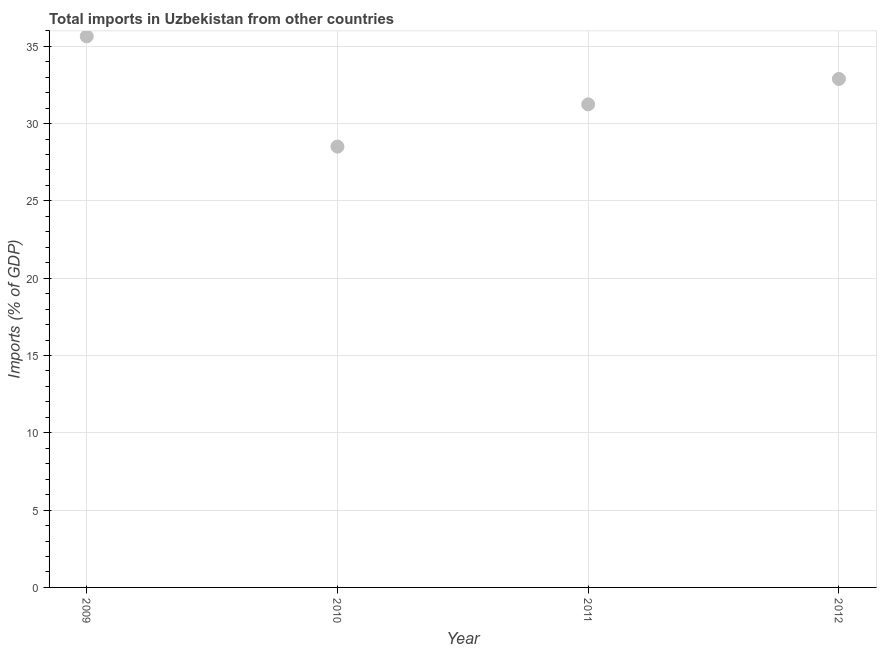What is the total imports in 2011?
Offer a terse response. 31.24. Across all years, what is the maximum total imports?
Make the answer very short. 35.65. Across all years, what is the minimum total imports?
Your answer should be compact. 28.51. What is the sum of the total imports?
Keep it short and to the point. 128.29. What is the difference between the total imports in 2009 and 2011?
Give a very brief answer. 4.4. What is the average total imports per year?
Your answer should be very brief. 32.07. What is the median total imports?
Ensure brevity in your answer.  32.07. What is the ratio of the total imports in 2011 to that in 2012?
Provide a short and direct response. 0.95. Is the total imports in 2009 less than that in 2011?
Ensure brevity in your answer.  No. What is the difference between the highest and the second highest total imports?
Make the answer very short. 2.76. Is the sum of the total imports in 2010 and 2011 greater than the maximum total imports across all years?
Your response must be concise. Yes. What is the difference between the highest and the lowest total imports?
Your response must be concise. 7.13. In how many years, is the total imports greater than the average total imports taken over all years?
Keep it short and to the point. 2. How many dotlines are there?
Keep it short and to the point. 1. What is the difference between two consecutive major ticks on the Y-axis?
Give a very brief answer. 5. Are the values on the major ticks of Y-axis written in scientific E-notation?
Ensure brevity in your answer.  No. Does the graph contain any zero values?
Your response must be concise. No. Does the graph contain grids?
Ensure brevity in your answer.  Yes. What is the title of the graph?
Provide a short and direct response. Total imports in Uzbekistan from other countries. What is the label or title of the Y-axis?
Provide a succinct answer. Imports (% of GDP). What is the Imports (% of GDP) in 2009?
Your answer should be compact. 35.65. What is the Imports (% of GDP) in 2010?
Your response must be concise. 28.51. What is the Imports (% of GDP) in 2011?
Offer a very short reply. 31.24. What is the Imports (% of GDP) in 2012?
Provide a succinct answer. 32.89. What is the difference between the Imports (% of GDP) in 2009 and 2010?
Keep it short and to the point. 7.13. What is the difference between the Imports (% of GDP) in 2009 and 2011?
Keep it short and to the point. 4.4. What is the difference between the Imports (% of GDP) in 2009 and 2012?
Offer a very short reply. 2.76. What is the difference between the Imports (% of GDP) in 2010 and 2011?
Offer a very short reply. -2.73. What is the difference between the Imports (% of GDP) in 2010 and 2012?
Offer a very short reply. -4.38. What is the difference between the Imports (% of GDP) in 2011 and 2012?
Make the answer very short. -1.65. What is the ratio of the Imports (% of GDP) in 2009 to that in 2010?
Your response must be concise. 1.25. What is the ratio of the Imports (% of GDP) in 2009 to that in 2011?
Make the answer very short. 1.14. What is the ratio of the Imports (% of GDP) in 2009 to that in 2012?
Give a very brief answer. 1.08. What is the ratio of the Imports (% of GDP) in 2010 to that in 2012?
Your response must be concise. 0.87. What is the ratio of the Imports (% of GDP) in 2011 to that in 2012?
Your answer should be compact. 0.95. 